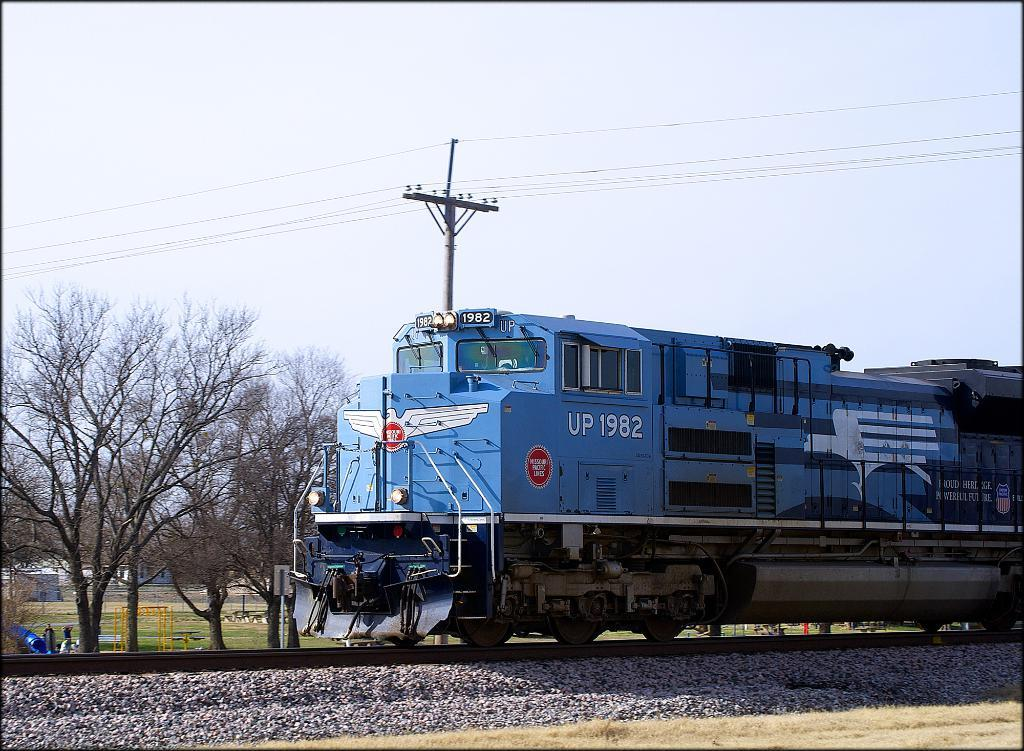Provide a one-sentence caption for the provided image. A blue train that says UP 1982 is going down a track under a power line. 